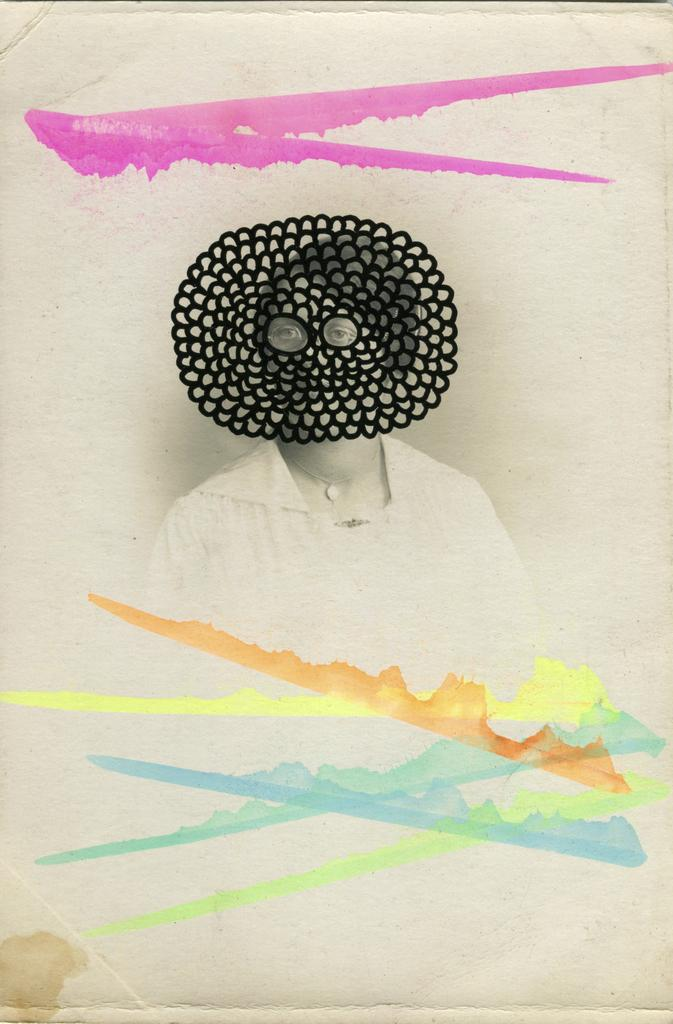What is depicted on the paper in the image? There is a picture of a woman on the paper. Are there any other artistic elements on the paper? Yes, there are paintings on the paper. What is the price of the park mentioned in the image? There is no mention of a park or any prices in the image. 